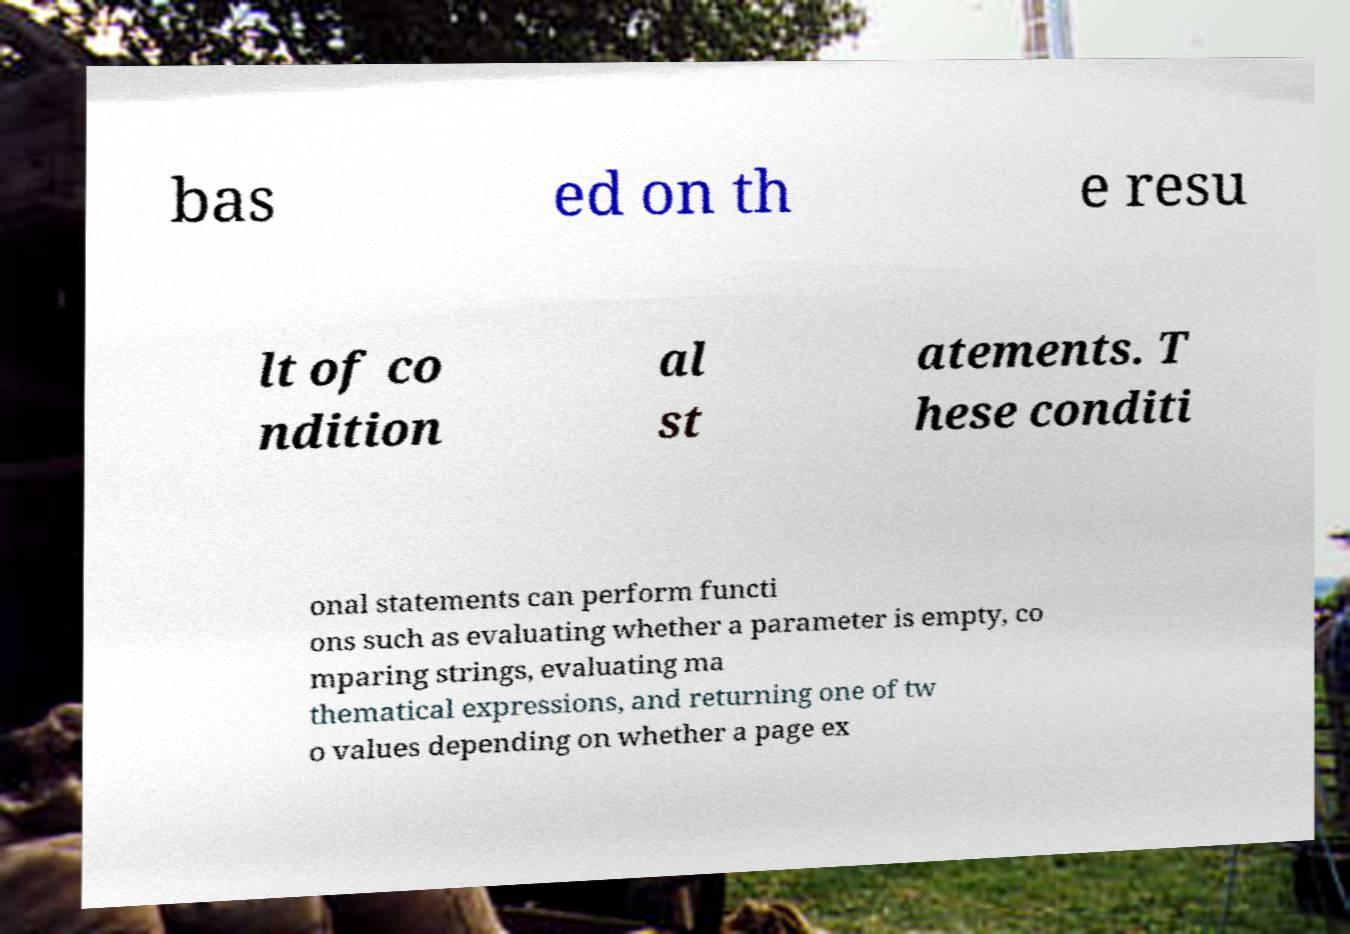Could you assist in decoding the text presented in this image and type it out clearly? bas ed on th e resu lt of co ndition al st atements. T hese conditi onal statements can perform functi ons such as evaluating whether a parameter is empty, co mparing strings, evaluating ma thematical expressions, and returning one of tw o values depending on whether a page ex 